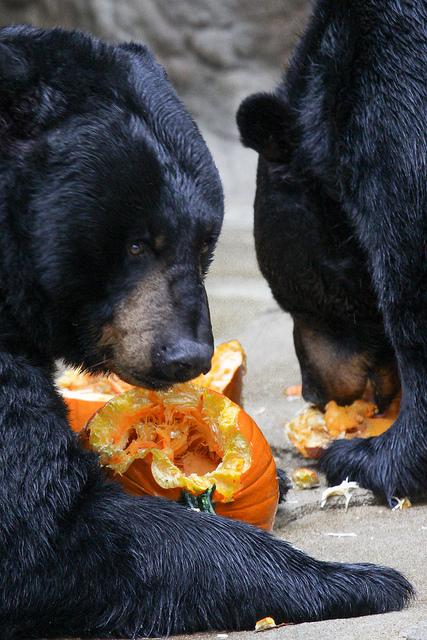Is this natural food they have found?
Concise answer only. Yes. What are these animals?
Short answer required. Bears. How many adult bears are in the picture?
Short answer required. 2. What is hanging out of this bears mouth?
Be succinct. Pumpkin. What food is the bear eating?
Keep it brief. Pumpkin. 